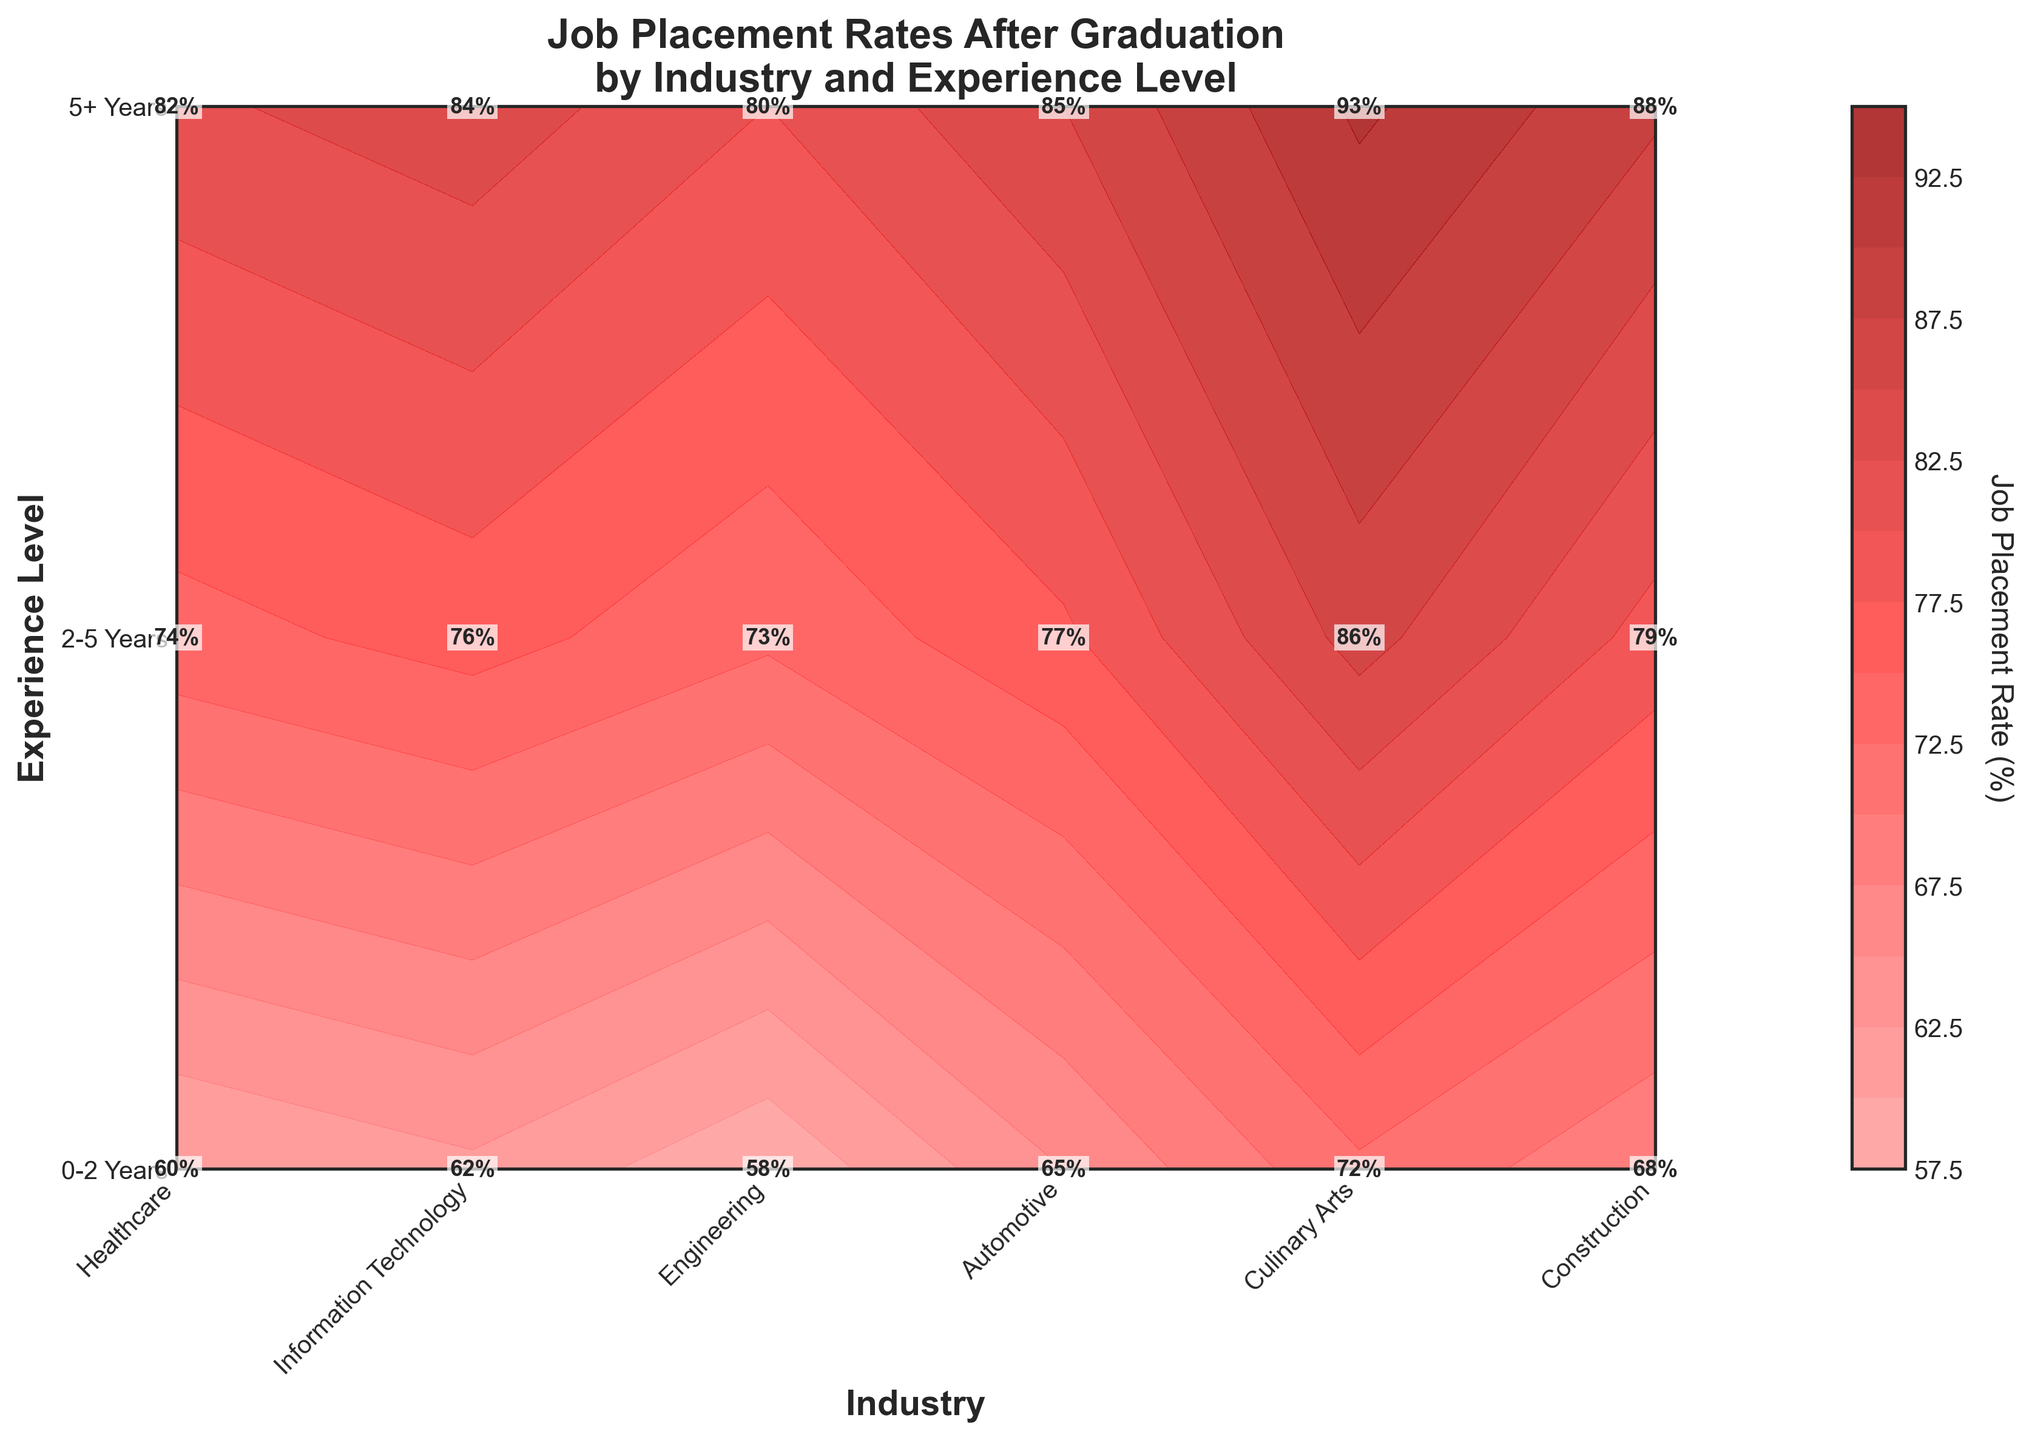What is the title of the figure? The title of the figure is prominently displayed at the top and indicates the content of the plot, which is about job placement rates across industries and experience levels.
Answer: Job Placement Rates After Graduation by Industry and Experience Level Which industry has the highest job placement rate for 5+ years of experience? By looking at the contour plot and the labels, we can see that the Healthcare industry has the highest rate with 93% for the 5+ years of experience level.
Answer: Healthcare What is the job placement rate for Information Technology with 0-2 years of experience? Locate the Information Technology industry on the x-axis and then move to the 0-2 years segment on the y-axis. The figure shows the value clearly.
Answer: 68% Compare the job placement rates between Healthcare and Engineering for the 2-5 years of experience level. Which one is higher and by how much? Find the data points for Healthcare and Engineering at the 2-5 years mark on the y-axis. Healthcare has a job placement rate of 86%, while Engineering has 77%. The difference is calculated by subtracting 77 from 86.
Answer: Healthcare is higher by 9% Which industry shows the lowest job placement rate for any experience level, and what is that rate? Scan through the contour plot and labels to identify the lowest percentage. Culinary Arts for the 0-2 years experience level has the lowest rate at 58%.
Answer: Culinary Arts at 58% Among the industries, which one shows a consistent increase in job placement rates with increasing experience levels? Observe the contour lines for each industry and note how the values change as experience increases. Healthcare shows a steady increase from 72% to 86% to 93%.
Answer: Healthcare For the Automotive industry, compute the average job placement rate across all experience levels. Add the rates for Automotive (60%, 74%, and 82%) and then divide by the number of experience levels (3). (60 + 74 + 82) / 3 = 216 / 3 = 72
Answer: 72 What is the color range used in the contour plot and what does it signify? The contour plot uses a color gradient from light red to dark red. This gradient signifies increasing job placement rates, with light red representing lower rates and dark red representing higher rates.
Answer: Light red to dark red, representing increasing job placement rates In terms of job placement rates, which experience level benefits the most across all industries? Review the general trend across all industries in the contour plot to see which experience level shows the highest rates. The 5+ years experience level consistently shows the highest job placement rates across all industries.
Answer: 5+ years Which experience level in the Construction industry has a job placement rate closest to 80%? Check the contour plot for Construction and identify the closest value to 80%. The rate for the 5+ years experience level is 84%, and the rate for the 2-5 years experience level is 76%. The 2-5 years experience level is closer to 80%.
Answer: 2-5 years 